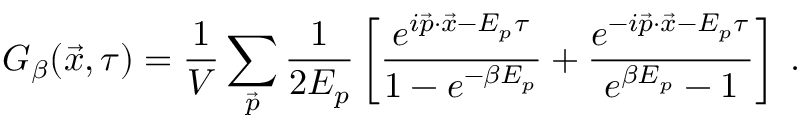<formula> <loc_0><loc_0><loc_500><loc_500>G _ { \beta } ( \vec { x } , \tau ) = { \frac { 1 } { V } } \sum _ { \vec { p } } { \frac { 1 } { 2 E _ { p } } } \left [ { \frac { e ^ { i \vec { p } \cdot \vec { x } - E _ { p } \tau } } { 1 - e ^ { - \beta E _ { p } } } } + { \frac { e ^ { - i \vec { p } \cdot \vec { x } - E _ { p } \tau } } { e ^ { \beta E _ { p } } - 1 } } \right ] \, .</formula> 